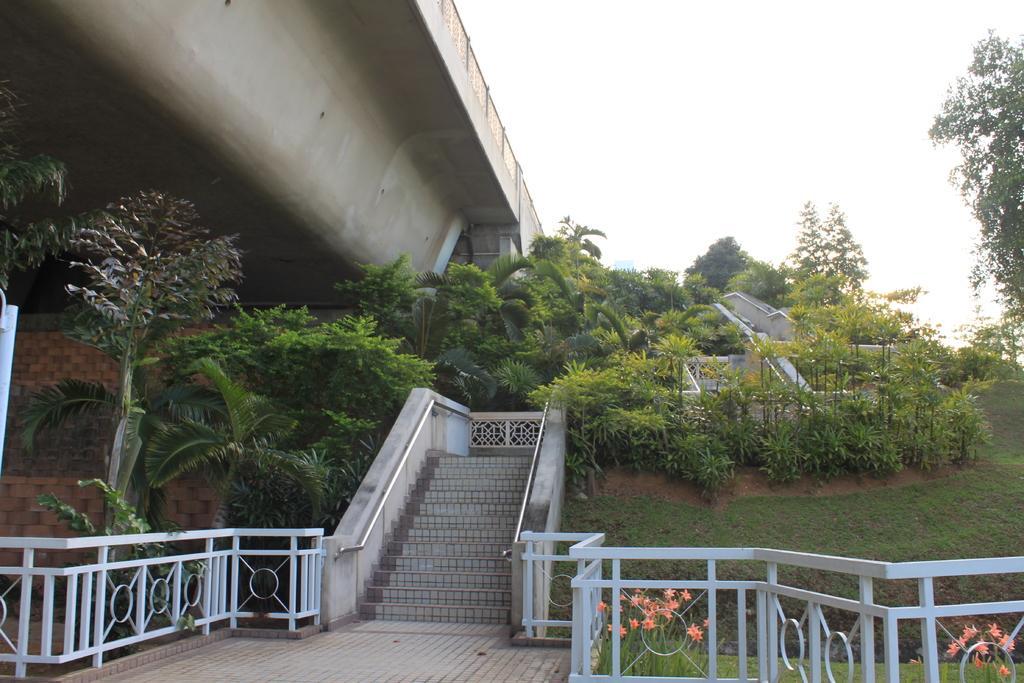Can you describe this image briefly? In this picture I can see the railings and steps in front and in the middle of this picture I can see number of plants, few flowers and the grass. On the top of this picture I can see the bridge, sky and few trees. 